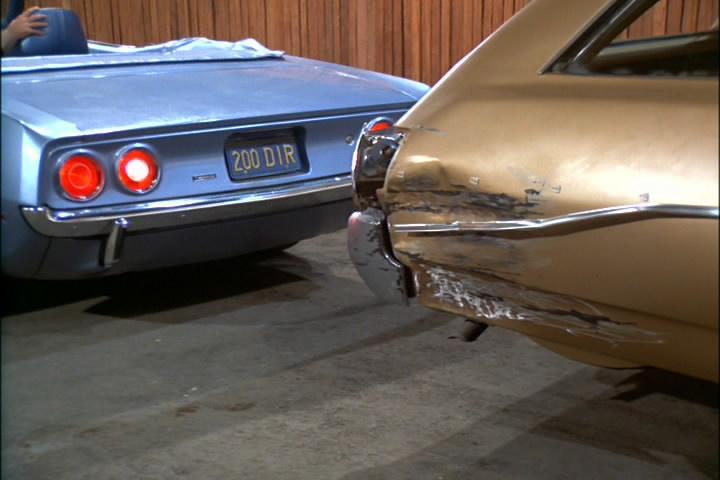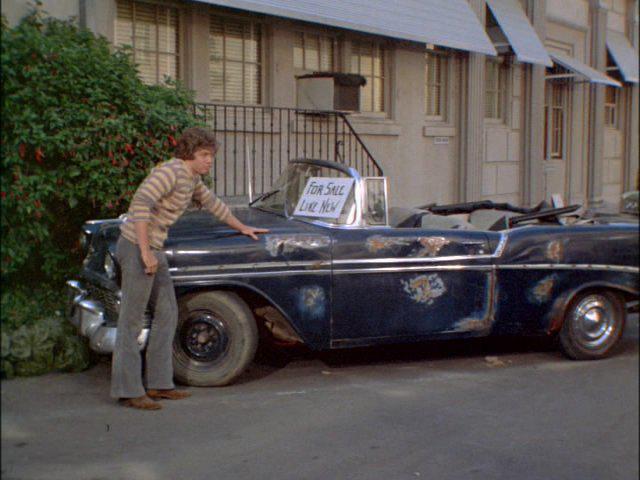The first image is the image on the left, the second image is the image on the right. Evaluate the accuracy of this statement regarding the images: "In the right image, there is a blue convertible facing the right". Is it true? Answer yes or no. No. 